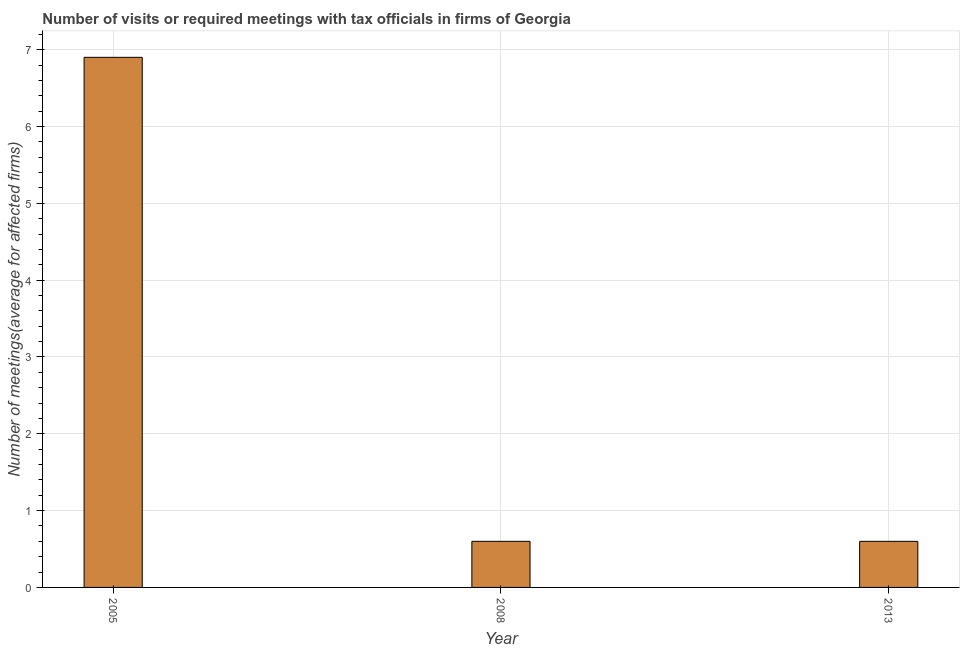Does the graph contain grids?
Your response must be concise. Yes. What is the title of the graph?
Keep it short and to the point. Number of visits or required meetings with tax officials in firms of Georgia. What is the label or title of the X-axis?
Your answer should be compact. Year. What is the label or title of the Y-axis?
Offer a very short reply. Number of meetings(average for affected firms). What is the number of required meetings with tax officials in 2005?
Offer a terse response. 6.9. In which year was the number of required meetings with tax officials maximum?
Provide a succinct answer. 2005. What is the difference between the number of required meetings with tax officials in 2005 and 2013?
Give a very brief answer. 6.3. What is the average number of required meetings with tax officials per year?
Ensure brevity in your answer.  2.7. In how many years, is the number of required meetings with tax officials greater than 2 ?
Your response must be concise. 1. Do a majority of the years between 2008 and 2005 (inclusive) have number of required meetings with tax officials greater than 2 ?
Offer a terse response. No. What is the ratio of the number of required meetings with tax officials in 2005 to that in 2013?
Ensure brevity in your answer.  11.5. Is the difference between the number of required meetings with tax officials in 2008 and 2013 greater than the difference between any two years?
Make the answer very short. No. Is the sum of the number of required meetings with tax officials in 2005 and 2008 greater than the maximum number of required meetings with tax officials across all years?
Offer a terse response. Yes. What is the difference between the highest and the lowest number of required meetings with tax officials?
Make the answer very short. 6.3. In how many years, is the number of required meetings with tax officials greater than the average number of required meetings with tax officials taken over all years?
Ensure brevity in your answer.  1. How many bars are there?
Give a very brief answer. 3. Are all the bars in the graph horizontal?
Your answer should be compact. No. Are the values on the major ticks of Y-axis written in scientific E-notation?
Your answer should be very brief. No. What is the Number of meetings(average for affected firms) in 2005?
Provide a succinct answer. 6.9. What is the Number of meetings(average for affected firms) in 2008?
Keep it short and to the point. 0.6. What is the difference between the Number of meetings(average for affected firms) in 2005 and 2008?
Keep it short and to the point. 6.3. What is the ratio of the Number of meetings(average for affected firms) in 2005 to that in 2008?
Your answer should be compact. 11.5. What is the ratio of the Number of meetings(average for affected firms) in 2008 to that in 2013?
Ensure brevity in your answer.  1. 